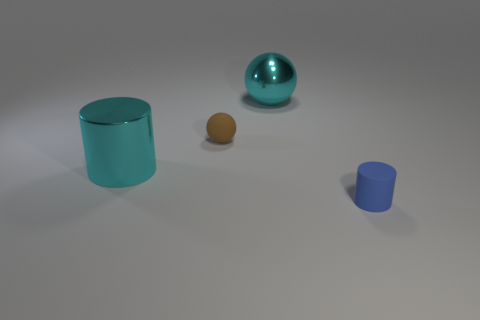Subtract all blue cylinders. How many cylinders are left? 1 Add 3 big cyan metal cylinders. How many objects exist? 7 Subtract 2 spheres. How many spheres are left? 0 Subtract all brown spheres. Subtract all purple cylinders. How many spheres are left? 1 Subtract all large cyan matte spheres. Subtract all metal spheres. How many objects are left? 3 Add 1 cyan spheres. How many cyan spheres are left? 2 Add 3 cyan rubber cylinders. How many cyan rubber cylinders exist? 3 Subtract 1 cyan spheres. How many objects are left? 3 